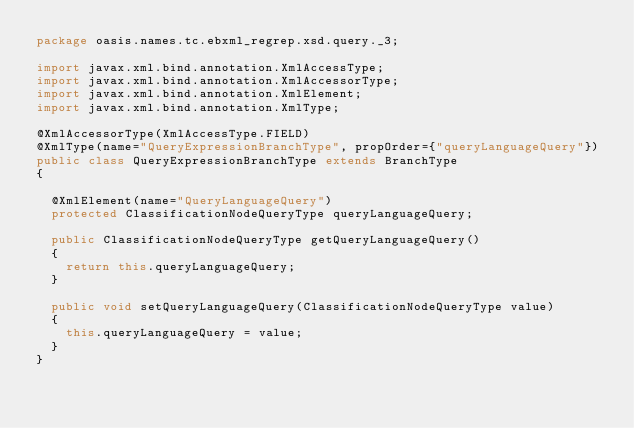<code> <loc_0><loc_0><loc_500><loc_500><_Java_>package oasis.names.tc.ebxml_regrep.xsd.query._3;

import javax.xml.bind.annotation.XmlAccessType;
import javax.xml.bind.annotation.XmlAccessorType;
import javax.xml.bind.annotation.XmlElement;
import javax.xml.bind.annotation.XmlType;

@XmlAccessorType(XmlAccessType.FIELD)
@XmlType(name="QueryExpressionBranchType", propOrder={"queryLanguageQuery"})
public class QueryExpressionBranchType extends BranchType
{

  @XmlElement(name="QueryLanguageQuery")
  protected ClassificationNodeQueryType queryLanguageQuery;

  public ClassificationNodeQueryType getQueryLanguageQuery()
  {
    return this.queryLanguageQuery;
  }

  public void setQueryLanguageQuery(ClassificationNodeQueryType value)
  {
    this.queryLanguageQuery = value;
  }
}

</code> 